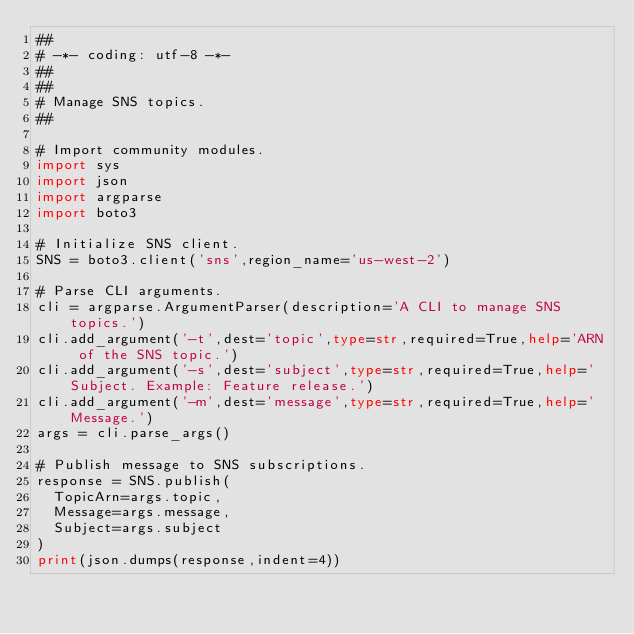Convert code to text. <code><loc_0><loc_0><loc_500><loc_500><_Python_>##
# -*- coding: utf-8 -*-
##
##
# Manage SNS topics.
##

# Import community modules.
import sys
import json
import argparse
import boto3

# Initialize SNS client.
SNS = boto3.client('sns',region_name='us-west-2')

# Parse CLI arguments.
cli = argparse.ArgumentParser(description='A CLI to manage SNS topics.')
cli.add_argument('-t',dest='topic',type=str,required=True,help='ARN of the SNS topic.')
cli.add_argument('-s',dest='subject',type=str,required=True,help='Subject. Example: Feature release.')
cli.add_argument('-m',dest='message',type=str,required=True,help='Message.')
args = cli.parse_args()

# Publish message to SNS subscriptions.
response = SNS.publish(
  TopicArn=args.topic,
  Message=args.message,
  Subject=args.subject
)
print(json.dumps(response,indent=4))
</code> 